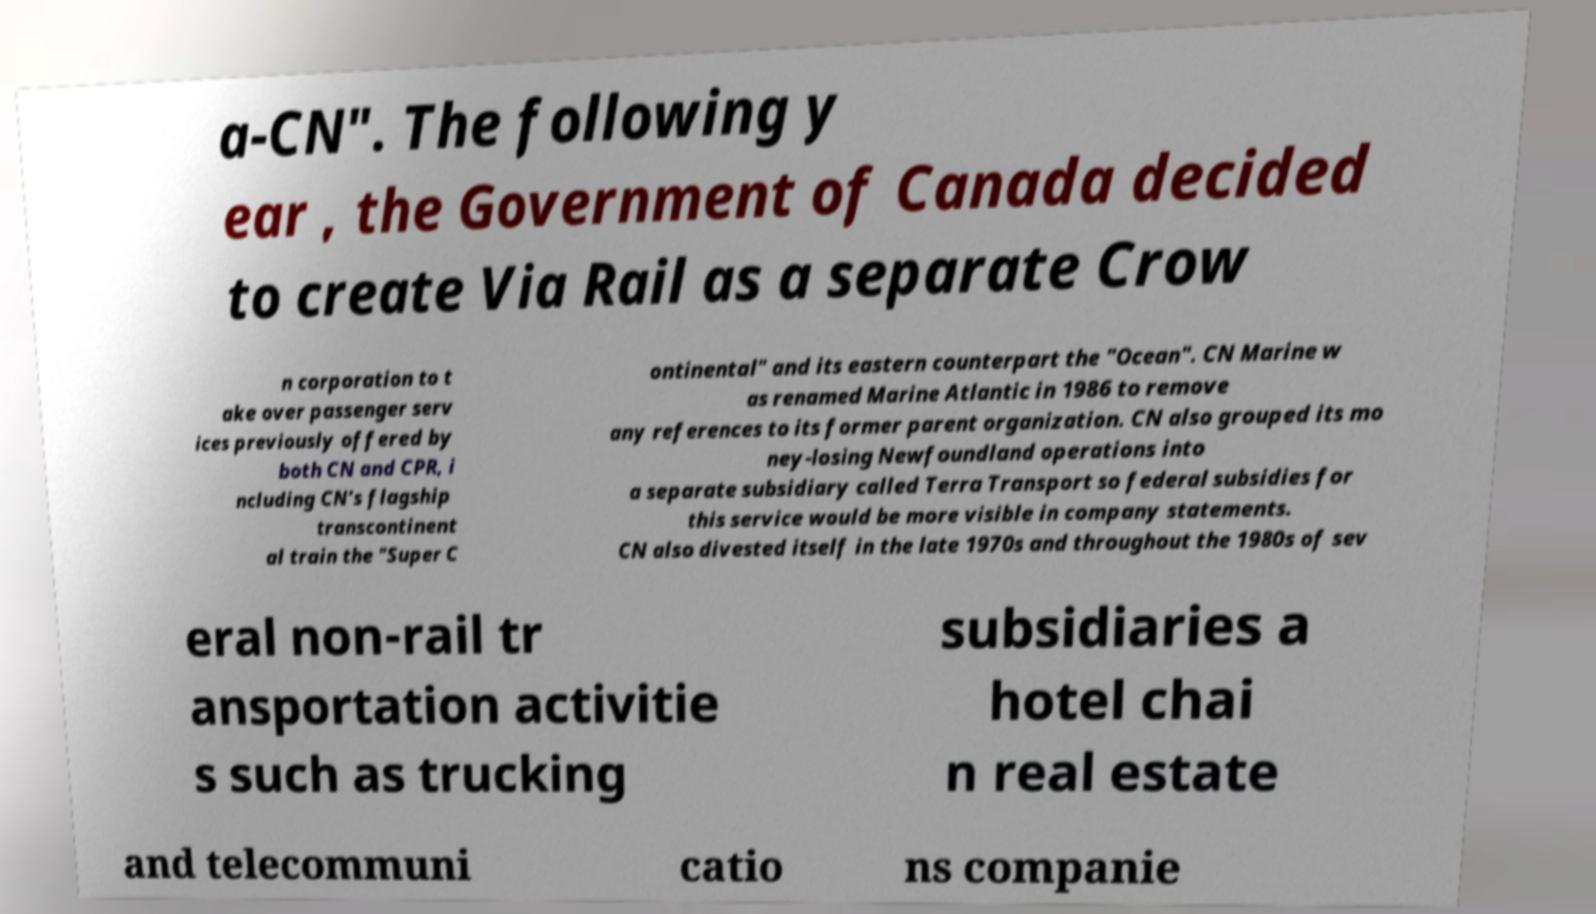Please read and relay the text visible in this image. What does it say? a-CN". The following y ear , the Government of Canada decided to create Via Rail as a separate Crow n corporation to t ake over passenger serv ices previously offered by both CN and CPR, i ncluding CN's flagship transcontinent al train the "Super C ontinental" and its eastern counterpart the "Ocean". CN Marine w as renamed Marine Atlantic in 1986 to remove any references to its former parent organization. CN also grouped its mo ney-losing Newfoundland operations into a separate subsidiary called Terra Transport so federal subsidies for this service would be more visible in company statements. CN also divested itself in the late 1970s and throughout the 1980s of sev eral non-rail tr ansportation activitie s such as trucking subsidiaries a hotel chai n real estate and telecommuni catio ns companie 